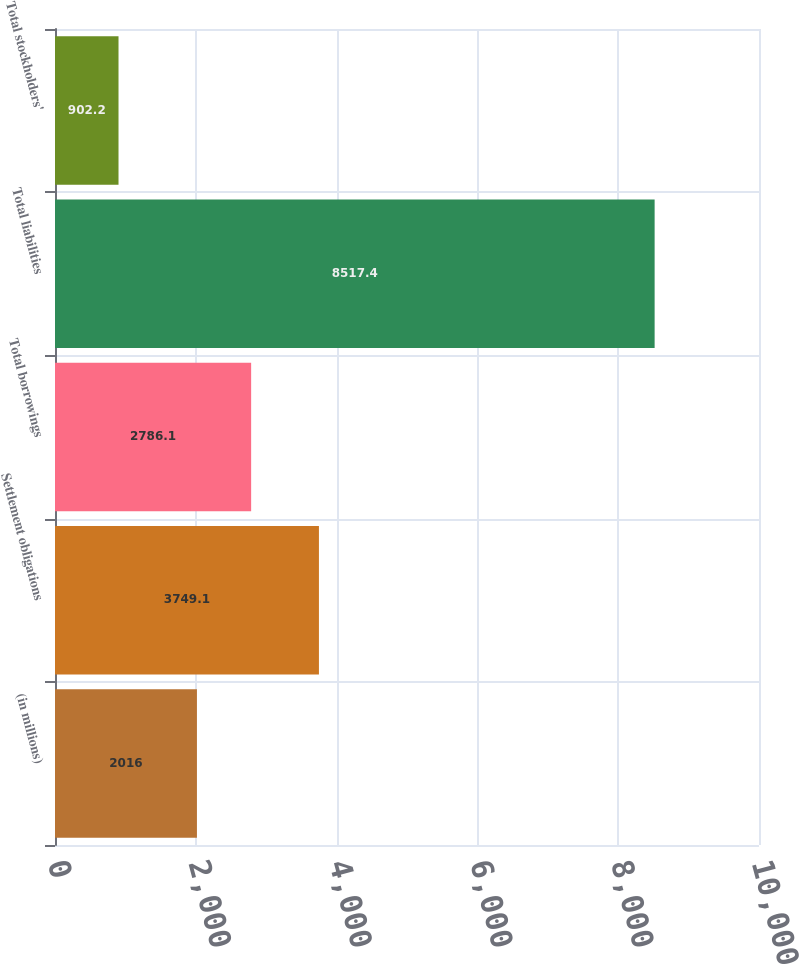Convert chart to OTSL. <chart><loc_0><loc_0><loc_500><loc_500><bar_chart><fcel>(in millions)<fcel>Settlement obligations<fcel>Total borrowings<fcel>Total liabilities<fcel>Total stockholders'<nl><fcel>2016<fcel>3749.1<fcel>2786.1<fcel>8517.4<fcel>902.2<nl></chart> 